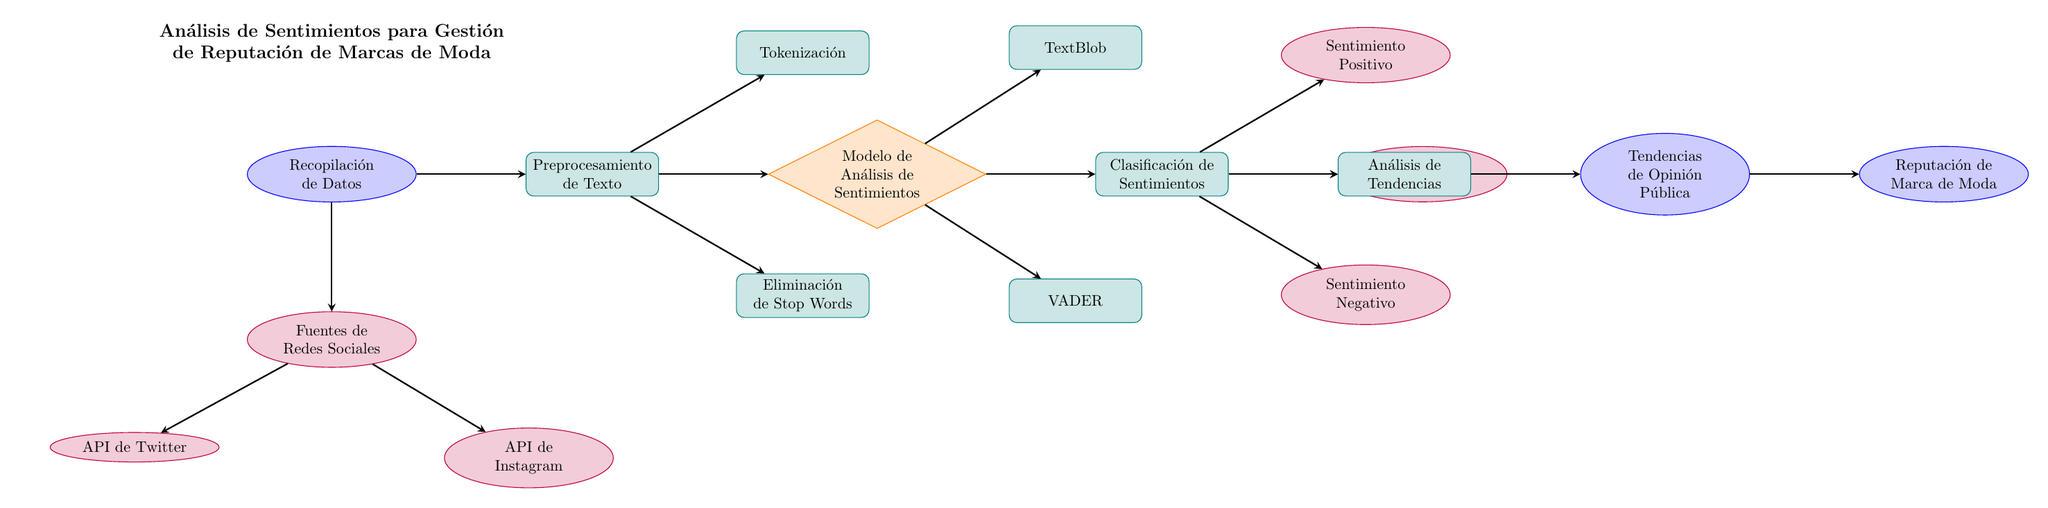¿Cuántas fuentes de redes sociales se indican en el diagrama? En el diagrama hay una nube llamada "Fuentes de Redes Sociales" desde la cual se ramifican dos nodos, que son "API de Twitter" y "API de Instagram". Esto indica que hay dos fuentes en total.
Answer: 2 ¿Cuál es el primer paso en el análisis de sentimientos? El primer paso es la "Recopilación de Datos", que se encuentra en la parte superior del diagrama y es la entrada principal antes de cualquier procesamiento.
Answer: Recopilación de Datos ¿Cuáles son los dos modelos de análisis de sentimientos mostrados en el diagrama? Los dos modelos de análisis de sentimientos se encuentran unidos al "Modelo de Análisis de Sentimientos" y son "TextBlob" y "VADER".
Answer: TextBlob, VADER ¿Qué tipo de sentimiento se clasifica en el diagrama? El diagrama muestra la clasificación de sentimientos en tres categorías: "Sentimiento Positivo", "Sentimiento Neutral" y "Sentimiento Negativo". Todo esto proviene de la etapa de "Clasificación de Sentimientos".
Answer: Sentimiento Positivo, Sentimiento Neutral, Sentimiento Negativo ¿Qué sucede después del análisis de tendencias? Después del "Análisis de Tendencias", se crean las "Tendencias de Opinión Pública", que se utilizan para evaluar la "Reputación de Marca de Moda". Esto muestra la relación entre los análisis previos y cómo influyen en la percepción de la marca.
Answer: Reputación de Marca de Moda ¿Cómo se relacionan "Eliminación de Stop Words" y "Tokenización"? Ambos nodos son procesos del paso "Preprocesamiento de Texto", lo que significa que son tareas que se realizan simultáneamente como parte del mismo flujo de trabajo para preparar los datos antes del análisis de sentimientos.
Answer: Son procesos en paralelo en Preprocesamiento de Texto ¿Cuál es el propósito del diagrama? El diagrama tiene el propósito de ilustrar el "Análisis de Sentimientos para Gestión de Reputación de Marcas de Moda", que es la finalidad general que conecta todos los nodos y procesos del diagrama.
Answer: Gestión de Reputación de Marcas de Moda 